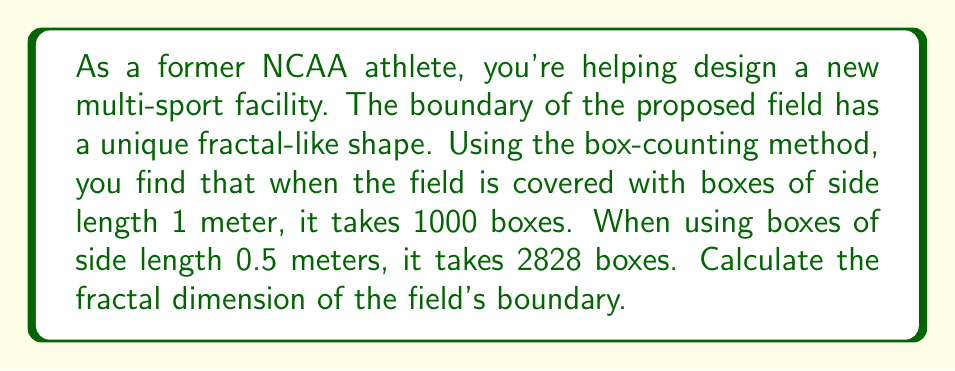Can you solve this math problem? To determine the fractal dimension using the box-counting method, we'll follow these steps:

1) The box-counting dimension is defined by the formula:

   $$D = \lim_{\epsilon \to 0} \frac{\log N(\epsilon)}{\log(1/\epsilon)}$$

   where $N(\epsilon)$ is the number of boxes of side length $\epsilon$ needed to cover the object.

2) We have two data points:
   - For $\epsilon_1 = 1$ m, $N(\epsilon_1) = 1000$
   - For $\epsilon_2 = 0.5$ m, $N(\epsilon_2) = 2828$

3) We can approximate the fractal dimension using these two points:

   $$D \approx \frac{\log(N(\epsilon_2)) - \log(N(\epsilon_1))}{\log(1/\epsilon_2) - \log(1/\epsilon_1)}$$

4) Substituting our values:

   $$D \approx \frac{\log(2828) - \log(1000)}{\log(1/0.5) - \log(1/1)}$$

5) Simplify:
   $$D \approx \frac{\log(2828) - \log(1000)}{\log(2) - \log(1)}$$

6) Calculate:
   $$D \approx \frac{3.4515 - 3.0000}{0.3010 - 0} \approx 1.5000$$

Therefore, the fractal dimension of the field's boundary is approximately 1.5.
Answer: 1.5 